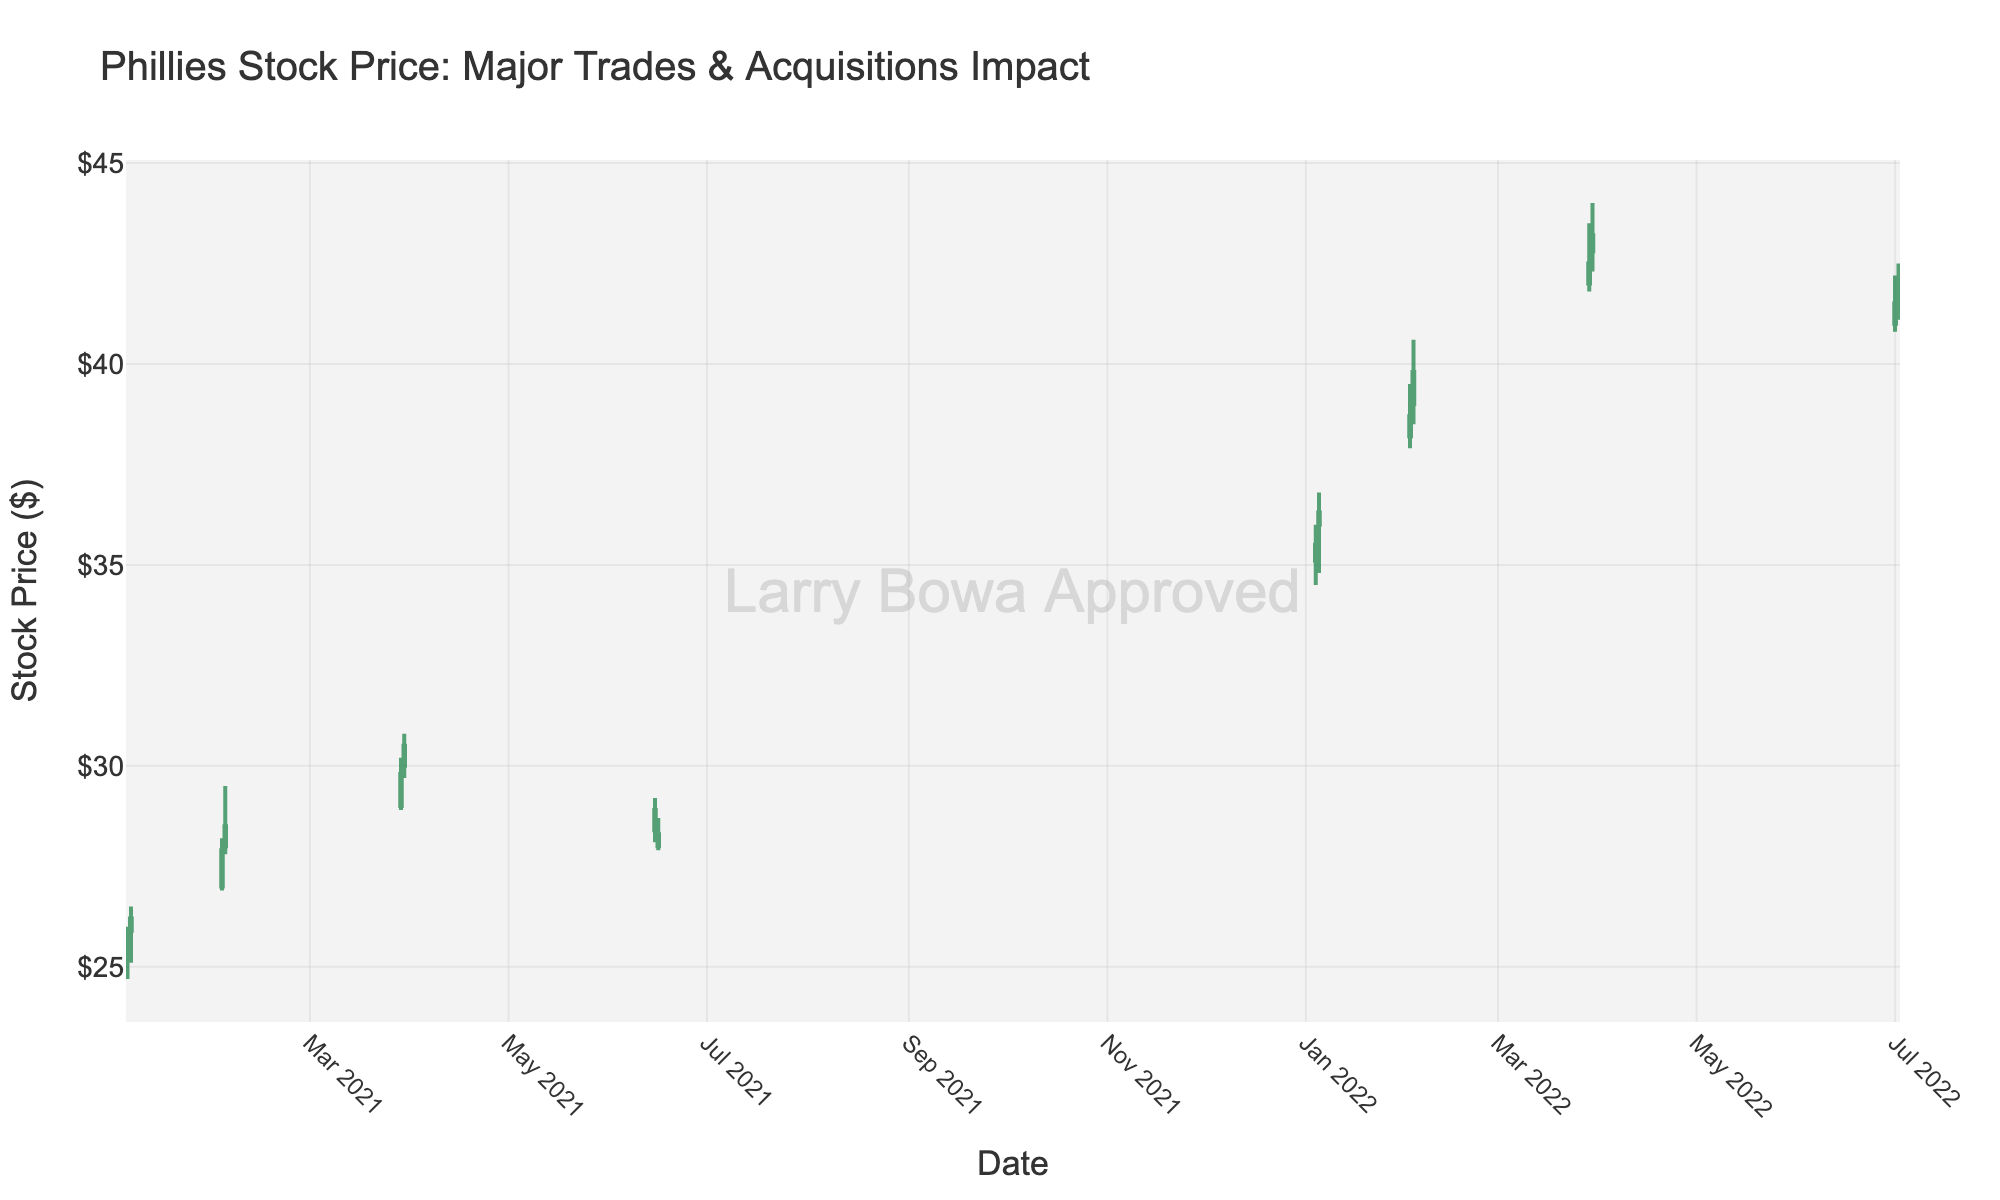What's the title of the chart? The title of the chart is visibly stated at the top of the figure. It reads: "Phillies Stock Price: Major Trades & Acquisitions Impact".
Answer: Phillies Stock Price: Major Trades & Acquisitions Impact How many candlesticks are there in the chart? Each candlestick represents one day of trading data. By counting the number of candlesticks visually present in the figure, you can determine the total. There are 16 distinct candlesticks.
Answer: 16 Which date saw the highest closing price in 2022? To determine this, examine the closing prices for candlesticks in 2022. The highest closing price in this year can be determined by comparing the values. The highest closing price in 2022 is on 2022-03-30 at $43.20.
Answer: 2022-03-30 What are the colors used to indicate increasing and decreasing candlesticks? The color of the candlestick indicates whether the stock price increased or decreased. By looking at the figure, it is clear that increasing candlesticks are green and decreasing candlesticks are red.
Answer: Green for increasing, red for decreasing What was the difference between the highest high and the lowest low in January 2021? To find this, identify the highest high and lowest low values within January 2021. For 2021-01-04 and 2021-01-05, the highest high is $26.50 and the lowest low is $24.70. The difference between these is calculated as $26.50 - $24.70 = $1.80.
Answer: $1.80 Did the stock price close higher or lower on 2021-02-02 compared to its opening price? To determine this, compare the opening and closing prices on 2021-02-02. The opening price is $27.00 and the closing price is $27.90. The closing price is higher.
Answer: Higher Which month in 2022 showed a consistent increase over two consecutive days and what were the closing prices on those days? Look for two consecutive days in 2022 where the closing price increased. In January 2022, on 2022-01-04 and 2022-01-05, the closing prices increased from $35.50 to $36.30.
Answer: January 2022, $35.50 and $36.30 What's the average closing price in March 2022? Sum the closing prices of the trading days in March 2022, and divide by the number of days. The closing prices are $42.50 and $43.20. The average is calculated as ($42.50 + $43.20)/2 = $42.85.
Answer: $42.85 Which day experienced the largest single-day price range in 2021 and what was the range? Examine each day's high and low prices to determine the day's price range and find the maximum. For 2021, on 2021-02-03, the range is $29.50 - $27.80 = $1.70, which is the largest.
Answer: 2021-02-03, $1.70 How does the stock price trend in June 2021 compare with March 2022? Visually compare the trends. In June 2021, the prices fluctuated but did not show a clear trend, while in March 2022, the prices showed a consistent increase.
Answer: No clear trend in June 2021, consistent increase in March 2022 